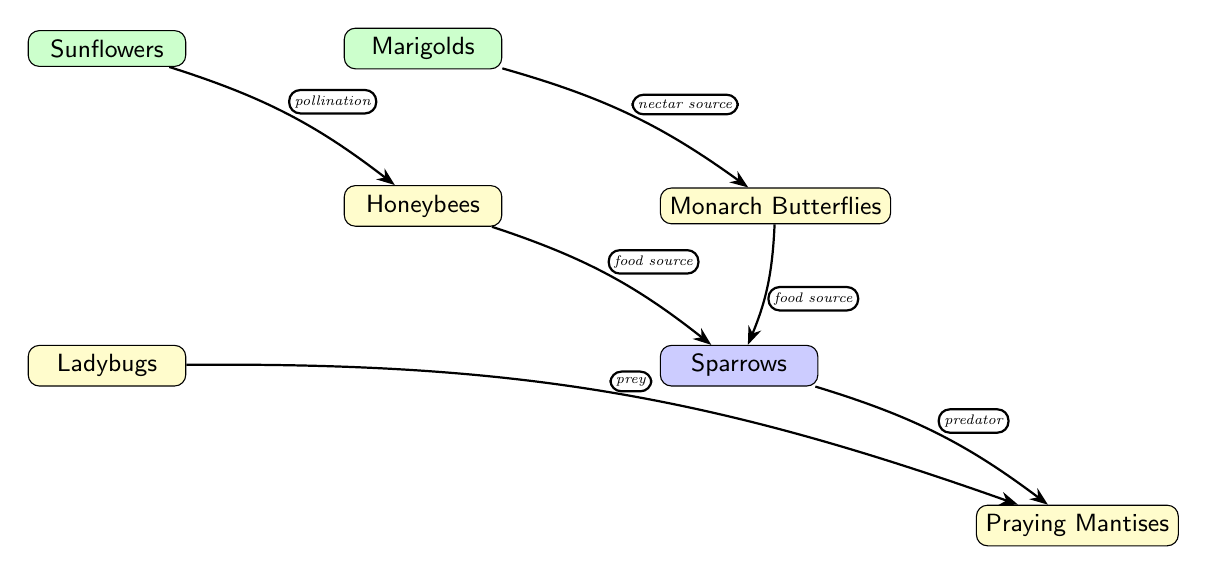What plants are involved in this food chain? The diagram shows two plant types: Sunflowers and Marigolds. These are the initial nodes in the food chain that support pollinators.
Answer: Sunflowers, Marigolds How many insects are represented in the diagram? The diagram includes three insects: Honeybees, Monarch Butterflies, and Ladybugs. This is found by counting the insect nodes present.
Answer: 3 What type of relationship connects the Sunflowers to the Honeybees? The edge connecting these two nodes is labeled "pollination," indicating the role of Sunflowers in supporting Honeybees through the process of pollination.
Answer: pollination Which bird preys on the Praying Mantises? The diagram shows that Sparrows have a relationship labeled "predator" with Praying Mantises, indicating that Sparrows feed on them.
Answer: Sparrows What is the food source for the Sparrows? Sparrows are connected via two edges to sources of food: Honeybees and Monarch Butterflies. Therefore, both insects serve as food sources for Sparrows.
Answer: Honeybees, Monarch Butterflies What insects are considered prey for Ladybugs? The diagram does not directly show relationships involving Ladybugs as prey but indicates that Ladybugs may feed on smaller insects typically found in urban gardens, which are not explicitly named. Hence, it’s implied but not detailed.
Answer: none specified What role do Marigolds play in this ecosystem? Marigolds provide nectar to Monarch Butterflies as indicated by the "nectar source" relationship depicted in the diagram between Marigolds and Monarch Butterflies.
Answer: nectar source Given that the relationship between Honeybees and Sparrows is defined in the diagram, what can we conclude about their roles in the food chain? Honeybees serve as a food source for Sparrows, indicating that Sparrows rely on Honeybees for nourishment, thereby showing their interconnected roles in this ecological food chain.
Answer: Honeybees to Sparrows Which node represents the predator in the food chain relationship with Praying Mantises? The edge leading to Praying Mantises is labeled "predator," which is attributed to Sparrows, signifying their position at the apex of this food web concerning Praying Mantises.
Answer: Sparrows 